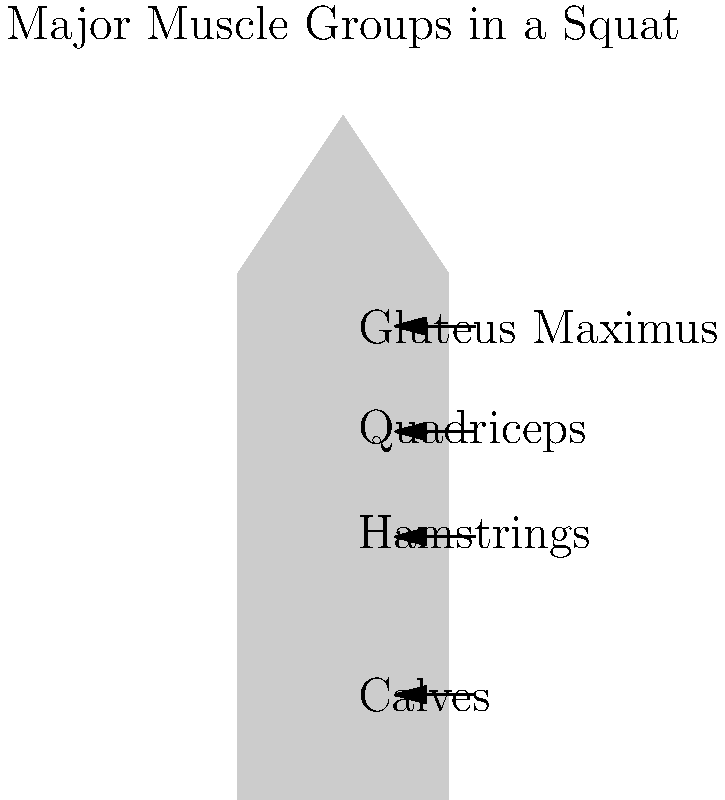Which of the following muscle groups is NOT primarily engaged during a squat exercise?
A) Quadriceps
B) Gluteus Maximus
C) Hamstrings
D) Biceps To answer this question, let's break down the major muscle groups involved in a squat exercise:

1. Quadriceps: Located on the front of the thigh, these muscles are heavily engaged during the squatting motion, particularly when extending the knee to stand up.

2. Gluteus Maximus: The largest muscle in the buttocks, it plays a crucial role in hip extension during the upward phase of the squat.

3. Hamstrings: Located on the back of the thigh, these muscles work alongside the gluteus maximus to extend the hip and also help control knee flexion.

4. Calves: While not as heavily involved as the above muscle groups, the calf muscles assist in stabilizing the ankle joint during the squat.

5. Core muscles: Although not shown in the diagram, the abdominal and lower back muscles are engaged to stabilize the trunk throughout the movement.

The biceps, which are located in the upper arm, are not primarily engaged during a squat exercise. They may be slightly activated if holding weights during the squat, but they are not a major contributor to the movement.

Therefore, the muscle group that is NOT primarily engaged during a squat exercise is the biceps.
Answer: D) Biceps 